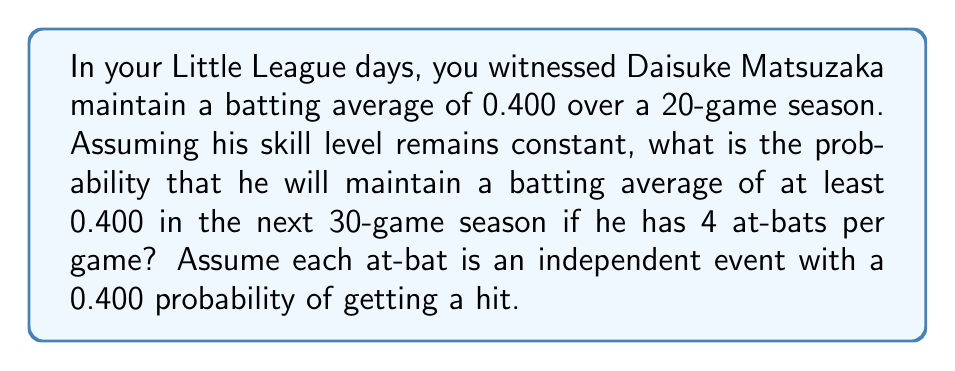Could you help me with this problem? Let's approach this step-by-step:

1) First, we need to calculate the total number of at-bats in the 30-game season:
   $30 \text{ games} \times 4 \text{ at-bats per game} = 120 \text{ at-bats}$

2) To maintain a batting average of at least 0.400, Daisuke needs to get at least 48 hits (0.400 × 120 = 48).

3) This scenario follows a binomial distribution with parameters:
   $n = 120$ (number of trials)
   $p = 0.400$ (probability of success on each trial)

4) We need to find $P(X \geq 48)$, where $X$ is the number of hits.

5) Using the binomial probability formula:

   $$P(X \geq 48) = \sum_{k=48}^{120} \binom{120}{k} (0.400)^k (0.600)^{120-k}$$

6) This sum is complex to calculate by hand, so we would typically use statistical software or tables.

7) Using a binomial probability calculator, we find:

   $P(X \geq 48) \approx 0.5388$

Therefore, the probability that Daisuke will maintain a batting average of at least 0.400 in the next 30-game season is approximately 0.5388 or 53.88%.
Answer: 0.5388 